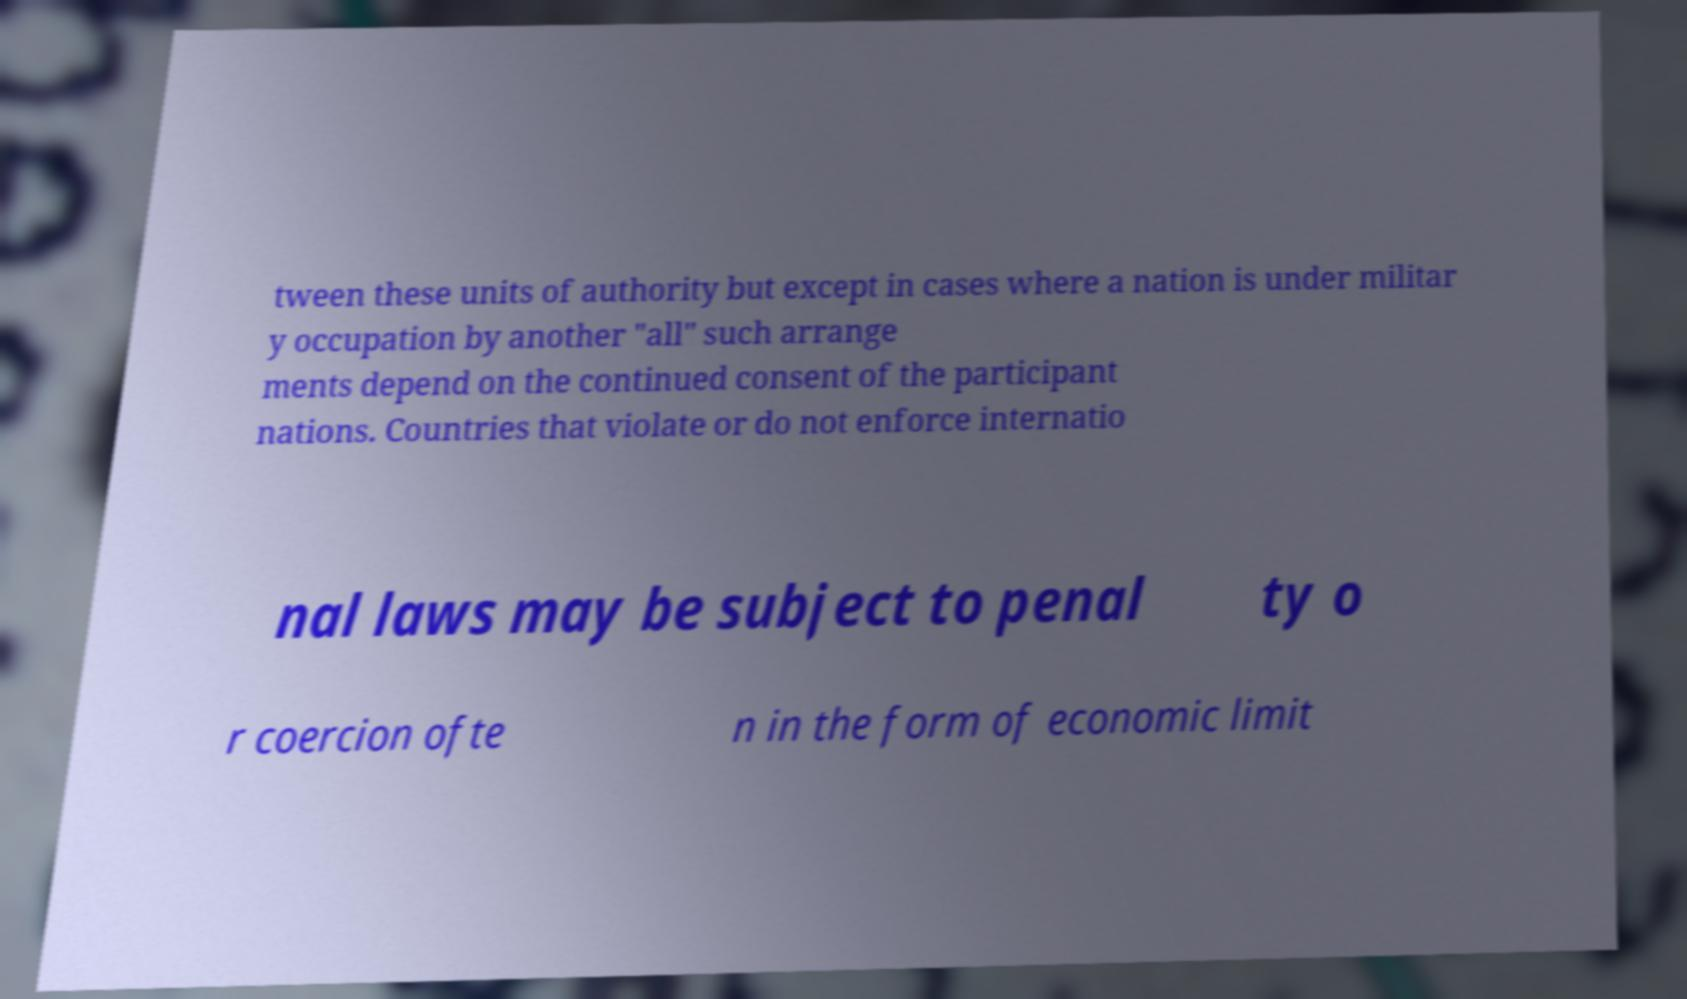For documentation purposes, I need the text within this image transcribed. Could you provide that? tween these units of authority but except in cases where a nation is under militar y occupation by another "all" such arrange ments depend on the continued consent of the participant nations. Countries that violate or do not enforce internatio nal laws may be subject to penal ty o r coercion ofte n in the form of economic limit 